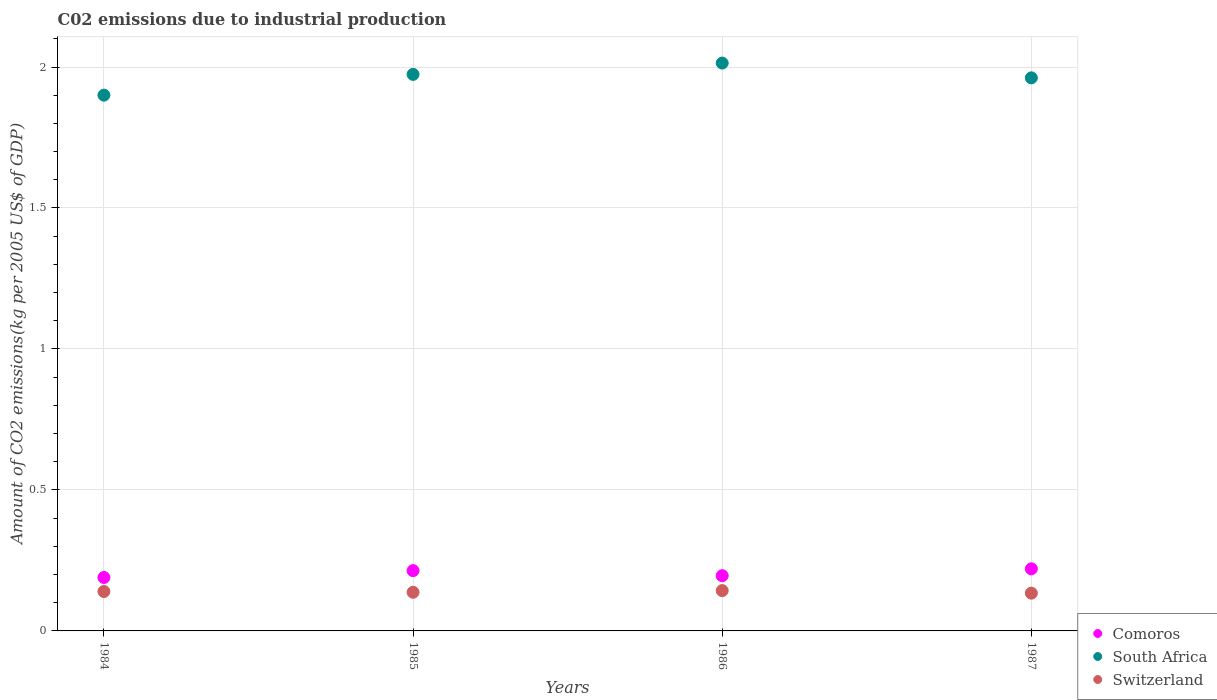How many different coloured dotlines are there?
Offer a very short reply. 3. Is the number of dotlines equal to the number of legend labels?
Make the answer very short. Yes. What is the amount of CO2 emitted due to industrial production in Comoros in 1987?
Give a very brief answer. 0.22. Across all years, what is the maximum amount of CO2 emitted due to industrial production in Comoros?
Your response must be concise. 0.22. Across all years, what is the minimum amount of CO2 emitted due to industrial production in Switzerland?
Keep it short and to the point. 0.13. In which year was the amount of CO2 emitted due to industrial production in South Africa minimum?
Your answer should be very brief. 1984. What is the total amount of CO2 emitted due to industrial production in Switzerland in the graph?
Your response must be concise. 0.55. What is the difference between the amount of CO2 emitted due to industrial production in South Africa in 1985 and that in 1986?
Your answer should be compact. -0.04. What is the difference between the amount of CO2 emitted due to industrial production in South Africa in 1985 and the amount of CO2 emitted due to industrial production in Comoros in 1987?
Ensure brevity in your answer.  1.75. What is the average amount of CO2 emitted due to industrial production in Comoros per year?
Your answer should be compact. 0.2. In the year 1984, what is the difference between the amount of CO2 emitted due to industrial production in Switzerland and amount of CO2 emitted due to industrial production in South Africa?
Give a very brief answer. -1.76. What is the ratio of the amount of CO2 emitted due to industrial production in Switzerland in 1984 to that in 1985?
Keep it short and to the point. 1.02. Is the difference between the amount of CO2 emitted due to industrial production in Switzerland in 1985 and 1987 greater than the difference between the amount of CO2 emitted due to industrial production in South Africa in 1985 and 1987?
Your answer should be very brief. No. What is the difference between the highest and the second highest amount of CO2 emitted due to industrial production in South Africa?
Your response must be concise. 0.04. What is the difference between the highest and the lowest amount of CO2 emitted due to industrial production in Switzerland?
Provide a short and direct response. 0.01. Is the sum of the amount of CO2 emitted due to industrial production in Comoros in 1984 and 1987 greater than the maximum amount of CO2 emitted due to industrial production in South Africa across all years?
Ensure brevity in your answer.  No. Does the amount of CO2 emitted due to industrial production in South Africa monotonically increase over the years?
Make the answer very short. No. How many years are there in the graph?
Provide a short and direct response. 4. What is the difference between two consecutive major ticks on the Y-axis?
Make the answer very short. 0.5. Are the values on the major ticks of Y-axis written in scientific E-notation?
Keep it short and to the point. No. Does the graph contain grids?
Offer a very short reply. Yes. Where does the legend appear in the graph?
Your answer should be very brief. Bottom right. How many legend labels are there?
Your answer should be compact. 3. What is the title of the graph?
Give a very brief answer. C02 emissions due to industrial production. What is the label or title of the X-axis?
Your answer should be very brief. Years. What is the label or title of the Y-axis?
Your response must be concise. Amount of CO2 emissions(kg per 2005 US$ of GDP). What is the Amount of CO2 emissions(kg per 2005 US$ of GDP) of Comoros in 1984?
Your answer should be compact. 0.19. What is the Amount of CO2 emissions(kg per 2005 US$ of GDP) in South Africa in 1984?
Provide a succinct answer. 1.9. What is the Amount of CO2 emissions(kg per 2005 US$ of GDP) in Switzerland in 1984?
Make the answer very short. 0.14. What is the Amount of CO2 emissions(kg per 2005 US$ of GDP) in Comoros in 1985?
Provide a succinct answer. 0.21. What is the Amount of CO2 emissions(kg per 2005 US$ of GDP) in South Africa in 1985?
Provide a short and direct response. 1.97. What is the Amount of CO2 emissions(kg per 2005 US$ of GDP) of Switzerland in 1985?
Ensure brevity in your answer.  0.14. What is the Amount of CO2 emissions(kg per 2005 US$ of GDP) of Comoros in 1986?
Provide a succinct answer. 0.2. What is the Amount of CO2 emissions(kg per 2005 US$ of GDP) in South Africa in 1986?
Give a very brief answer. 2.01. What is the Amount of CO2 emissions(kg per 2005 US$ of GDP) of Switzerland in 1986?
Your answer should be very brief. 0.14. What is the Amount of CO2 emissions(kg per 2005 US$ of GDP) in Comoros in 1987?
Give a very brief answer. 0.22. What is the Amount of CO2 emissions(kg per 2005 US$ of GDP) of South Africa in 1987?
Make the answer very short. 1.96. What is the Amount of CO2 emissions(kg per 2005 US$ of GDP) in Switzerland in 1987?
Give a very brief answer. 0.13. Across all years, what is the maximum Amount of CO2 emissions(kg per 2005 US$ of GDP) of Comoros?
Give a very brief answer. 0.22. Across all years, what is the maximum Amount of CO2 emissions(kg per 2005 US$ of GDP) in South Africa?
Your answer should be compact. 2.01. Across all years, what is the maximum Amount of CO2 emissions(kg per 2005 US$ of GDP) of Switzerland?
Ensure brevity in your answer.  0.14. Across all years, what is the minimum Amount of CO2 emissions(kg per 2005 US$ of GDP) of Comoros?
Give a very brief answer. 0.19. Across all years, what is the minimum Amount of CO2 emissions(kg per 2005 US$ of GDP) of South Africa?
Your answer should be compact. 1.9. Across all years, what is the minimum Amount of CO2 emissions(kg per 2005 US$ of GDP) of Switzerland?
Give a very brief answer. 0.13. What is the total Amount of CO2 emissions(kg per 2005 US$ of GDP) of Comoros in the graph?
Keep it short and to the point. 0.82. What is the total Amount of CO2 emissions(kg per 2005 US$ of GDP) in South Africa in the graph?
Ensure brevity in your answer.  7.85. What is the total Amount of CO2 emissions(kg per 2005 US$ of GDP) in Switzerland in the graph?
Provide a succinct answer. 0.55. What is the difference between the Amount of CO2 emissions(kg per 2005 US$ of GDP) of Comoros in 1984 and that in 1985?
Your answer should be very brief. -0.02. What is the difference between the Amount of CO2 emissions(kg per 2005 US$ of GDP) of South Africa in 1984 and that in 1985?
Your response must be concise. -0.07. What is the difference between the Amount of CO2 emissions(kg per 2005 US$ of GDP) in Switzerland in 1984 and that in 1985?
Offer a terse response. 0. What is the difference between the Amount of CO2 emissions(kg per 2005 US$ of GDP) in Comoros in 1984 and that in 1986?
Your answer should be compact. -0.01. What is the difference between the Amount of CO2 emissions(kg per 2005 US$ of GDP) in South Africa in 1984 and that in 1986?
Your response must be concise. -0.11. What is the difference between the Amount of CO2 emissions(kg per 2005 US$ of GDP) of Switzerland in 1984 and that in 1986?
Keep it short and to the point. -0. What is the difference between the Amount of CO2 emissions(kg per 2005 US$ of GDP) in Comoros in 1984 and that in 1987?
Your answer should be compact. -0.03. What is the difference between the Amount of CO2 emissions(kg per 2005 US$ of GDP) in South Africa in 1984 and that in 1987?
Offer a very short reply. -0.06. What is the difference between the Amount of CO2 emissions(kg per 2005 US$ of GDP) of Switzerland in 1984 and that in 1987?
Provide a short and direct response. 0.01. What is the difference between the Amount of CO2 emissions(kg per 2005 US$ of GDP) in Comoros in 1985 and that in 1986?
Your answer should be compact. 0.02. What is the difference between the Amount of CO2 emissions(kg per 2005 US$ of GDP) of South Africa in 1985 and that in 1986?
Offer a very short reply. -0.04. What is the difference between the Amount of CO2 emissions(kg per 2005 US$ of GDP) in Switzerland in 1985 and that in 1986?
Provide a succinct answer. -0.01. What is the difference between the Amount of CO2 emissions(kg per 2005 US$ of GDP) in Comoros in 1985 and that in 1987?
Give a very brief answer. -0.01. What is the difference between the Amount of CO2 emissions(kg per 2005 US$ of GDP) in South Africa in 1985 and that in 1987?
Provide a succinct answer. 0.01. What is the difference between the Amount of CO2 emissions(kg per 2005 US$ of GDP) in Switzerland in 1985 and that in 1987?
Your answer should be compact. 0. What is the difference between the Amount of CO2 emissions(kg per 2005 US$ of GDP) in Comoros in 1986 and that in 1987?
Offer a terse response. -0.02. What is the difference between the Amount of CO2 emissions(kg per 2005 US$ of GDP) in South Africa in 1986 and that in 1987?
Provide a succinct answer. 0.05. What is the difference between the Amount of CO2 emissions(kg per 2005 US$ of GDP) in Switzerland in 1986 and that in 1987?
Your answer should be compact. 0.01. What is the difference between the Amount of CO2 emissions(kg per 2005 US$ of GDP) in Comoros in 1984 and the Amount of CO2 emissions(kg per 2005 US$ of GDP) in South Africa in 1985?
Your answer should be compact. -1.78. What is the difference between the Amount of CO2 emissions(kg per 2005 US$ of GDP) of Comoros in 1984 and the Amount of CO2 emissions(kg per 2005 US$ of GDP) of Switzerland in 1985?
Provide a short and direct response. 0.05. What is the difference between the Amount of CO2 emissions(kg per 2005 US$ of GDP) in South Africa in 1984 and the Amount of CO2 emissions(kg per 2005 US$ of GDP) in Switzerland in 1985?
Offer a terse response. 1.76. What is the difference between the Amount of CO2 emissions(kg per 2005 US$ of GDP) of Comoros in 1984 and the Amount of CO2 emissions(kg per 2005 US$ of GDP) of South Africa in 1986?
Your answer should be compact. -1.82. What is the difference between the Amount of CO2 emissions(kg per 2005 US$ of GDP) of Comoros in 1984 and the Amount of CO2 emissions(kg per 2005 US$ of GDP) of Switzerland in 1986?
Your response must be concise. 0.05. What is the difference between the Amount of CO2 emissions(kg per 2005 US$ of GDP) of South Africa in 1984 and the Amount of CO2 emissions(kg per 2005 US$ of GDP) of Switzerland in 1986?
Your answer should be compact. 1.76. What is the difference between the Amount of CO2 emissions(kg per 2005 US$ of GDP) of Comoros in 1984 and the Amount of CO2 emissions(kg per 2005 US$ of GDP) of South Africa in 1987?
Your answer should be very brief. -1.77. What is the difference between the Amount of CO2 emissions(kg per 2005 US$ of GDP) of Comoros in 1984 and the Amount of CO2 emissions(kg per 2005 US$ of GDP) of Switzerland in 1987?
Provide a short and direct response. 0.06. What is the difference between the Amount of CO2 emissions(kg per 2005 US$ of GDP) in South Africa in 1984 and the Amount of CO2 emissions(kg per 2005 US$ of GDP) in Switzerland in 1987?
Provide a short and direct response. 1.77. What is the difference between the Amount of CO2 emissions(kg per 2005 US$ of GDP) of Comoros in 1985 and the Amount of CO2 emissions(kg per 2005 US$ of GDP) of South Africa in 1986?
Provide a short and direct response. -1.8. What is the difference between the Amount of CO2 emissions(kg per 2005 US$ of GDP) of Comoros in 1985 and the Amount of CO2 emissions(kg per 2005 US$ of GDP) of Switzerland in 1986?
Keep it short and to the point. 0.07. What is the difference between the Amount of CO2 emissions(kg per 2005 US$ of GDP) in South Africa in 1985 and the Amount of CO2 emissions(kg per 2005 US$ of GDP) in Switzerland in 1986?
Provide a short and direct response. 1.83. What is the difference between the Amount of CO2 emissions(kg per 2005 US$ of GDP) in Comoros in 1985 and the Amount of CO2 emissions(kg per 2005 US$ of GDP) in South Africa in 1987?
Your response must be concise. -1.75. What is the difference between the Amount of CO2 emissions(kg per 2005 US$ of GDP) of Comoros in 1985 and the Amount of CO2 emissions(kg per 2005 US$ of GDP) of Switzerland in 1987?
Make the answer very short. 0.08. What is the difference between the Amount of CO2 emissions(kg per 2005 US$ of GDP) of South Africa in 1985 and the Amount of CO2 emissions(kg per 2005 US$ of GDP) of Switzerland in 1987?
Your response must be concise. 1.84. What is the difference between the Amount of CO2 emissions(kg per 2005 US$ of GDP) of Comoros in 1986 and the Amount of CO2 emissions(kg per 2005 US$ of GDP) of South Africa in 1987?
Your answer should be very brief. -1.77. What is the difference between the Amount of CO2 emissions(kg per 2005 US$ of GDP) of Comoros in 1986 and the Amount of CO2 emissions(kg per 2005 US$ of GDP) of Switzerland in 1987?
Your response must be concise. 0.06. What is the difference between the Amount of CO2 emissions(kg per 2005 US$ of GDP) of South Africa in 1986 and the Amount of CO2 emissions(kg per 2005 US$ of GDP) of Switzerland in 1987?
Ensure brevity in your answer.  1.88. What is the average Amount of CO2 emissions(kg per 2005 US$ of GDP) in Comoros per year?
Provide a short and direct response. 0.2. What is the average Amount of CO2 emissions(kg per 2005 US$ of GDP) of South Africa per year?
Make the answer very short. 1.96. What is the average Amount of CO2 emissions(kg per 2005 US$ of GDP) in Switzerland per year?
Provide a succinct answer. 0.14. In the year 1984, what is the difference between the Amount of CO2 emissions(kg per 2005 US$ of GDP) of Comoros and Amount of CO2 emissions(kg per 2005 US$ of GDP) of South Africa?
Ensure brevity in your answer.  -1.71. In the year 1984, what is the difference between the Amount of CO2 emissions(kg per 2005 US$ of GDP) in Comoros and Amount of CO2 emissions(kg per 2005 US$ of GDP) in Switzerland?
Offer a terse response. 0.05. In the year 1984, what is the difference between the Amount of CO2 emissions(kg per 2005 US$ of GDP) in South Africa and Amount of CO2 emissions(kg per 2005 US$ of GDP) in Switzerland?
Your response must be concise. 1.76. In the year 1985, what is the difference between the Amount of CO2 emissions(kg per 2005 US$ of GDP) of Comoros and Amount of CO2 emissions(kg per 2005 US$ of GDP) of South Africa?
Keep it short and to the point. -1.76. In the year 1985, what is the difference between the Amount of CO2 emissions(kg per 2005 US$ of GDP) in Comoros and Amount of CO2 emissions(kg per 2005 US$ of GDP) in Switzerland?
Provide a succinct answer. 0.08. In the year 1985, what is the difference between the Amount of CO2 emissions(kg per 2005 US$ of GDP) in South Africa and Amount of CO2 emissions(kg per 2005 US$ of GDP) in Switzerland?
Keep it short and to the point. 1.84. In the year 1986, what is the difference between the Amount of CO2 emissions(kg per 2005 US$ of GDP) of Comoros and Amount of CO2 emissions(kg per 2005 US$ of GDP) of South Africa?
Your response must be concise. -1.82. In the year 1986, what is the difference between the Amount of CO2 emissions(kg per 2005 US$ of GDP) in Comoros and Amount of CO2 emissions(kg per 2005 US$ of GDP) in Switzerland?
Make the answer very short. 0.05. In the year 1986, what is the difference between the Amount of CO2 emissions(kg per 2005 US$ of GDP) of South Africa and Amount of CO2 emissions(kg per 2005 US$ of GDP) of Switzerland?
Provide a succinct answer. 1.87. In the year 1987, what is the difference between the Amount of CO2 emissions(kg per 2005 US$ of GDP) in Comoros and Amount of CO2 emissions(kg per 2005 US$ of GDP) in South Africa?
Provide a short and direct response. -1.74. In the year 1987, what is the difference between the Amount of CO2 emissions(kg per 2005 US$ of GDP) of Comoros and Amount of CO2 emissions(kg per 2005 US$ of GDP) of Switzerland?
Give a very brief answer. 0.09. In the year 1987, what is the difference between the Amount of CO2 emissions(kg per 2005 US$ of GDP) of South Africa and Amount of CO2 emissions(kg per 2005 US$ of GDP) of Switzerland?
Provide a short and direct response. 1.83. What is the ratio of the Amount of CO2 emissions(kg per 2005 US$ of GDP) in Comoros in 1984 to that in 1985?
Your response must be concise. 0.89. What is the ratio of the Amount of CO2 emissions(kg per 2005 US$ of GDP) of South Africa in 1984 to that in 1985?
Offer a very short reply. 0.96. What is the ratio of the Amount of CO2 emissions(kg per 2005 US$ of GDP) in Switzerland in 1984 to that in 1985?
Offer a terse response. 1.02. What is the ratio of the Amount of CO2 emissions(kg per 2005 US$ of GDP) of Comoros in 1984 to that in 1986?
Keep it short and to the point. 0.97. What is the ratio of the Amount of CO2 emissions(kg per 2005 US$ of GDP) of South Africa in 1984 to that in 1986?
Provide a succinct answer. 0.94. What is the ratio of the Amount of CO2 emissions(kg per 2005 US$ of GDP) of Switzerland in 1984 to that in 1986?
Ensure brevity in your answer.  0.98. What is the ratio of the Amount of CO2 emissions(kg per 2005 US$ of GDP) of Comoros in 1984 to that in 1987?
Provide a short and direct response. 0.86. What is the ratio of the Amount of CO2 emissions(kg per 2005 US$ of GDP) of South Africa in 1984 to that in 1987?
Keep it short and to the point. 0.97. What is the ratio of the Amount of CO2 emissions(kg per 2005 US$ of GDP) in Switzerland in 1984 to that in 1987?
Ensure brevity in your answer.  1.04. What is the ratio of the Amount of CO2 emissions(kg per 2005 US$ of GDP) in Comoros in 1985 to that in 1986?
Offer a terse response. 1.09. What is the ratio of the Amount of CO2 emissions(kg per 2005 US$ of GDP) of South Africa in 1985 to that in 1986?
Your answer should be very brief. 0.98. What is the ratio of the Amount of CO2 emissions(kg per 2005 US$ of GDP) in Switzerland in 1985 to that in 1986?
Your answer should be compact. 0.96. What is the ratio of the Amount of CO2 emissions(kg per 2005 US$ of GDP) of Comoros in 1985 to that in 1987?
Give a very brief answer. 0.97. What is the ratio of the Amount of CO2 emissions(kg per 2005 US$ of GDP) of South Africa in 1985 to that in 1987?
Keep it short and to the point. 1.01. What is the ratio of the Amount of CO2 emissions(kg per 2005 US$ of GDP) in Switzerland in 1985 to that in 1987?
Provide a short and direct response. 1.02. What is the ratio of the Amount of CO2 emissions(kg per 2005 US$ of GDP) of Comoros in 1986 to that in 1987?
Your answer should be compact. 0.89. What is the ratio of the Amount of CO2 emissions(kg per 2005 US$ of GDP) in South Africa in 1986 to that in 1987?
Your response must be concise. 1.03. What is the ratio of the Amount of CO2 emissions(kg per 2005 US$ of GDP) of Switzerland in 1986 to that in 1987?
Provide a short and direct response. 1.07. What is the difference between the highest and the second highest Amount of CO2 emissions(kg per 2005 US$ of GDP) of Comoros?
Give a very brief answer. 0.01. What is the difference between the highest and the second highest Amount of CO2 emissions(kg per 2005 US$ of GDP) of South Africa?
Provide a short and direct response. 0.04. What is the difference between the highest and the second highest Amount of CO2 emissions(kg per 2005 US$ of GDP) of Switzerland?
Offer a terse response. 0. What is the difference between the highest and the lowest Amount of CO2 emissions(kg per 2005 US$ of GDP) of Comoros?
Provide a short and direct response. 0.03. What is the difference between the highest and the lowest Amount of CO2 emissions(kg per 2005 US$ of GDP) in South Africa?
Ensure brevity in your answer.  0.11. What is the difference between the highest and the lowest Amount of CO2 emissions(kg per 2005 US$ of GDP) of Switzerland?
Your answer should be very brief. 0.01. 